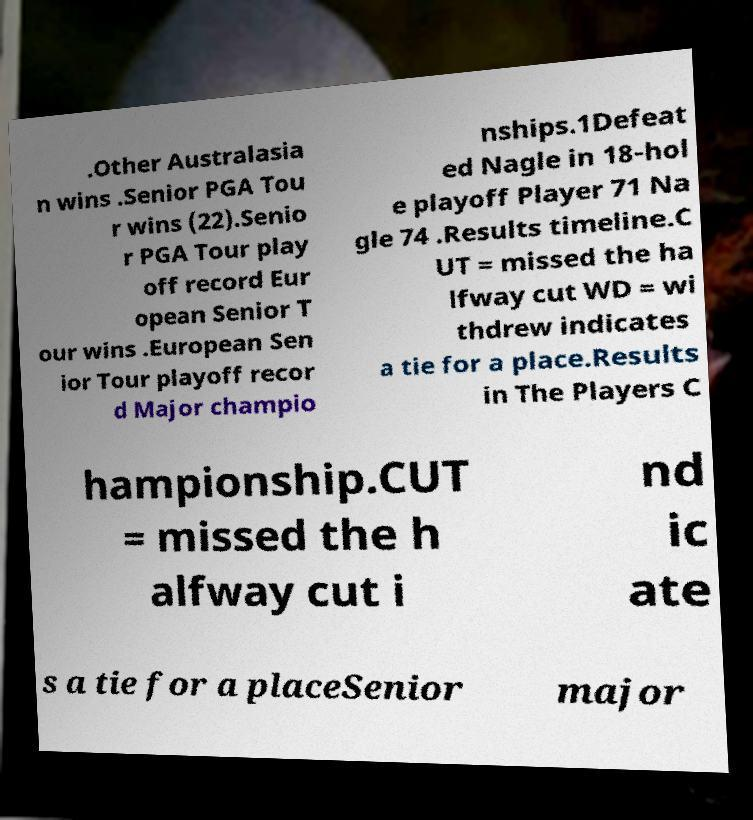Could you extract and type out the text from this image? .Other Australasia n wins .Senior PGA Tou r wins (22).Senio r PGA Tour play off record Eur opean Senior T our wins .European Sen ior Tour playoff recor d Major champio nships.1Defeat ed Nagle in 18-hol e playoff Player 71 Na gle 74 .Results timeline.C UT = missed the ha lfway cut WD = wi thdrew indicates a tie for a place.Results in The Players C hampionship.CUT = missed the h alfway cut i nd ic ate s a tie for a placeSenior major 